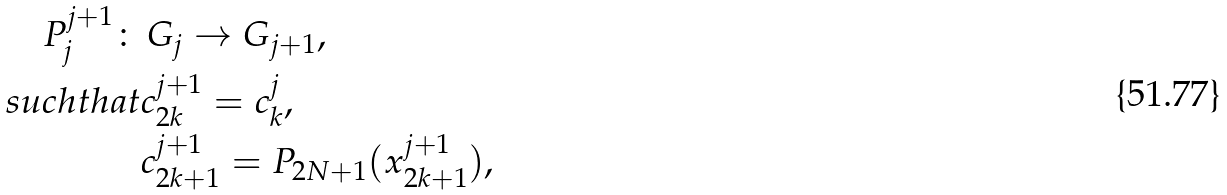<formula> <loc_0><loc_0><loc_500><loc_500>P _ { j } ^ { j + 1 } \colon & \, G _ { j } \rightarrow G _ { j + 1 } , \\ s u c h t h a t & c _ { 2 k } ^ { j + 1 } = c _ { k } ^ { j } , \\ & c _ { 2 k + 1 } ^ { j + 1 } = P _ { 2 N + 1 } ( x _ { 2 k + 1 } ^ { j + 1 } ) , \\</formula> 